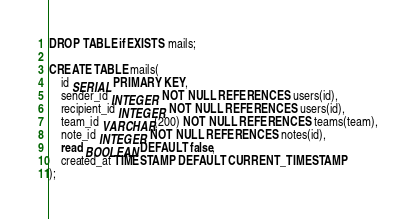Convert code to text. <code><loc_0><loc_0><loc_500><loc_500><_SQL_>DROP TABLE if EXISTS mails;

CREATE TABLE mails(
    id SERIAL PRIMARY KEY,
    sender_id INTEGER NOT NULL REFERENCES users(id),
    recipient_id INTEGER NOT NULL REFERENCES users(id),
    team_id VARCHAR(200) NOT NULL REFERENCES teams(team),
    note_id INTEGER NOT NULL REFERENCES notes(id),  
    read BOOLEAN DEFAULT false, 
    created_at TIMESTAMP DEFAULT CURRENT_TIMESTAMP
);</code> 